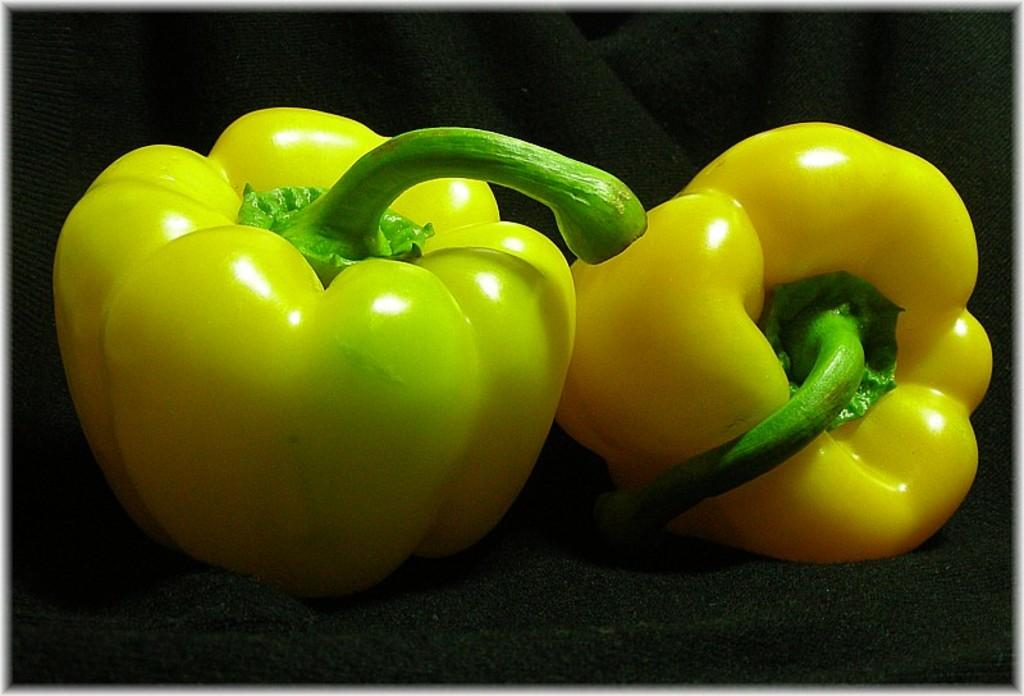What type of lizards can be seen in the image? There are no lizards present in the image; it features capsicums in yellow and green colors on a black surface. What is the range of colors of the capsicums in the image? The capsicums in the image are in yellow and green colors. What is the color of the surface on which the capsicums are placed? The capsicums are on a black color surface. What type of destruction can be seen happening to the capsicums in the image? There is no destruction happening to the capsicums in the image; they are simply placed on a black surface. 